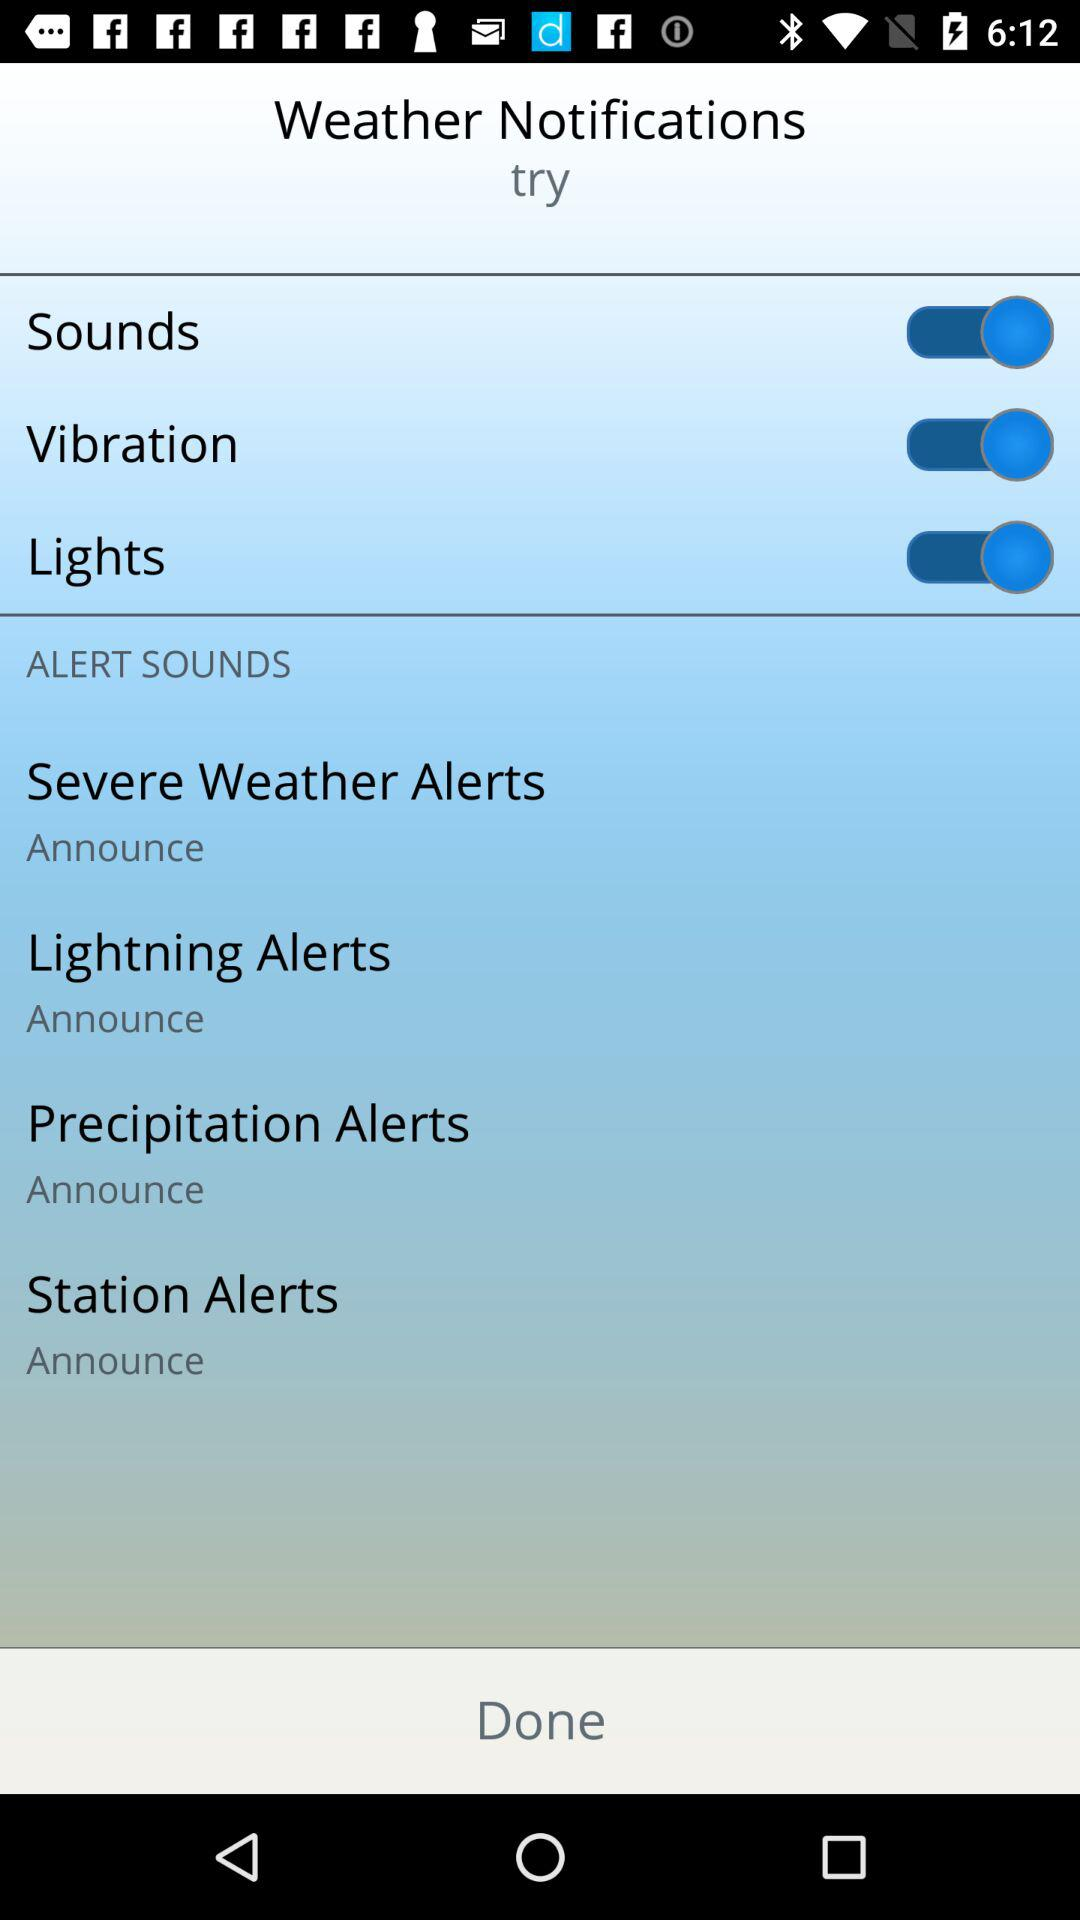What is the setting for the "Station Alerts"? The setting is "Announce". 